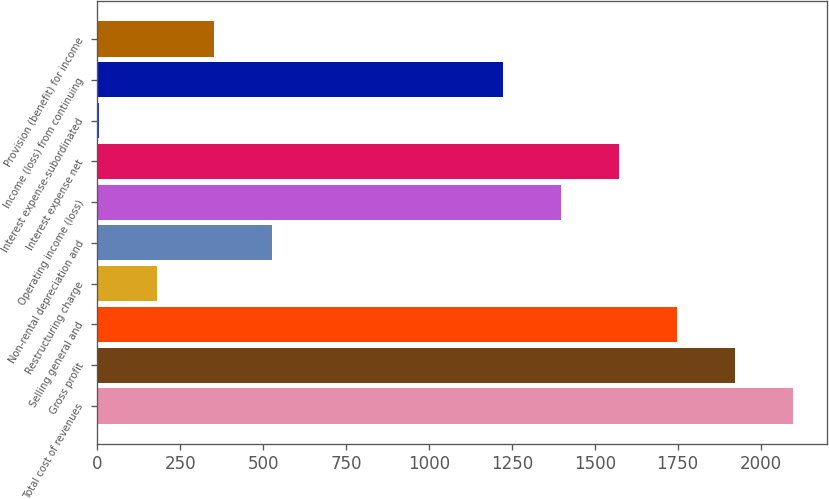Convert chart to OTSL. <chart><loc_0><loc_0><loc_500><loc_500><bar_chart><fcel>Total cost of revenues<fcel>Gross profit<fcel>Selling general and<fcel>Restructuring charge<fcel>Non-rental depreciation and<fcel>Operating income (loss)<fcel>Interest expense net<fcel>Interest expense-subordinated<fcel>Income (loss) from continuing<fcel>Provision (benefit) for income<nl><fcel>2096.8<fcel>1922.4<fcel>1748<fcel>178.4<fcel>527.2<fcel>1399.2<fcel>1573.6<fcel>4<fcel>1224.8<fcel>352.8<nl></chart> 